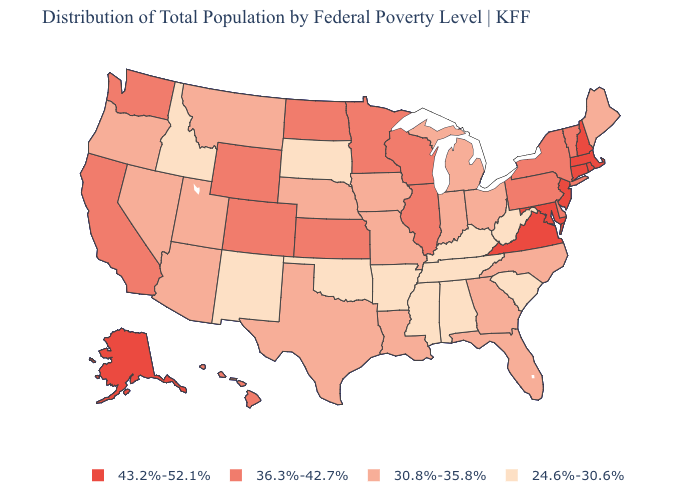Does Maine have the lowest value in the Northeast?
Concise answer only. Yes. Name the states that have a value in the range 24.6%-30.6%?
Write a very short answer. Alabama, Arkansas, Idaho, Kentucky, Mississippi, New Mexico, Oklahoma, South Carolina, South Dakota, Tennessee, West Virginia. Which states have the highest value in the USA?
Concise answer only. Alaska, Connecticut, Maryland, Massachusetts, New Hampshire, New Jersey, Rhode Island, Virginia. Does Massachusetts have the highest value in the USA?
Quick response, please. Yes. Does New Jersey have the highest value in the USA?
Concise answer only. Yes. Among the states that border Oregon , does Nevada have the highest value?
Be succinct. No. What is the lowest value in the Northeast?
Short answer required. 30.8%-35.8%. What is the highest value in states that border Nebraska?
Answer briefly. 36.3%-42.7%. Name the states that have a value in the range 30.8%-35.8%?
Keep it brief. Arizona, Florida, Georgia, Indiana, Iowa, Louisiana, Maine, Michigan, Missouri, Montana, Nebraska, Nevada, North Carolina, Ohio, Oregon, Texas, Utah. What is the lowest value in states that border Maryland?
Quick response, please. 24.6%-30.6%. Which states have the lowest value in the South?
Answer briefly. Alabama, Arkansas, Kentucky, Mississippi, Oklahoma, South Carolina, Tennessee, West Virginia. Which states have the lowest value in the USA?
Quick response, please. Alabama, Arkansas, Idaho, Kentucky, Mississippi, New Mexico, Oklahoma, South Carolina, South Dakota, Tennessee, West Virginia. Among the states that border Louisiana , does Texas have the highest value?
Short answer required. Yes. What is the value of Indiana?
Answer briefly. 30.8%-35.8%. Among the states that border Mississippi , does Louisiana have the highest value?
Short answer required. Yes. 